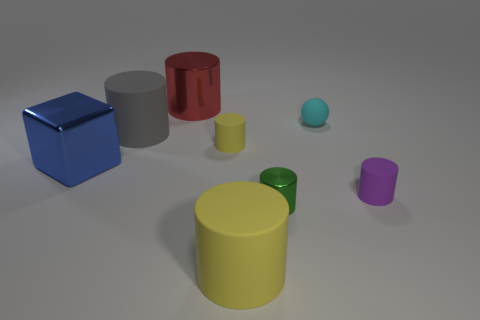Add 1 large green shiny cylinders. How many objects exist? 9 Subtract all green cylinders. How many cylinders are left? 5 Subtract all red cylinders. How many cylinders are left? 5 Subtract 1 blocks. How many blocks are left? 0 Add 4 cyan objects. How many cyan objects are left? 5 Add 3 small red cylinders. How many small red cylinders exist? 3 Subtract 0 yellow blocks. How many objects are left? 8 Subtract all spheres. How many objects are left? 7 Subtract all blue spheres. Subtract all brown cylinders. How many spheres are left? 1 Subtract all blue spheres. How many red blocks are left? 0 